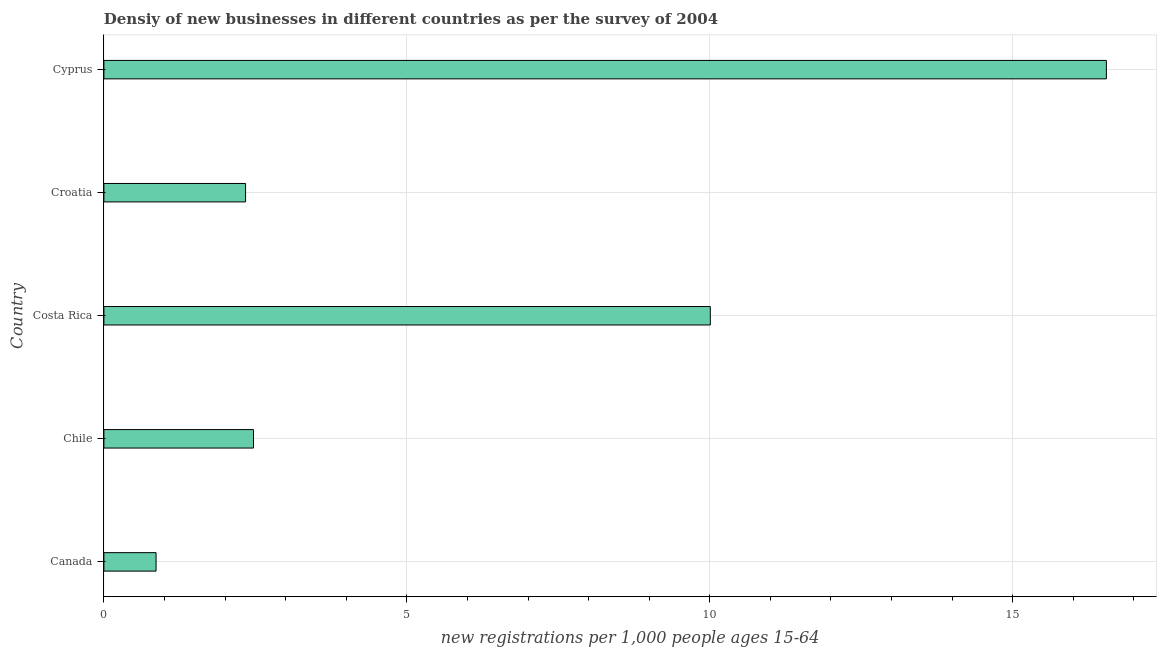Does the graph contain any zero values?
Offer a very short reply. No. Does the graph contain grids?
Your answer should be very brief. Yes. What is the title of the graph?
Offer a very short reply. Densiy of new businesses in different countries as per the survey of 2004. What is the label or title of the X-axis?
Offer a very short reply. New registrations per 1,0 people ages 15-64. What is the density of new business in Cyprus?
Offer a very short reply. 16.55. Across all countries, what is the maximum density of new business?
Provide a succinct answer. 16.55. Across all countries, what is the minimum density of new business?
Give a very brief answer. 0.86. In which country was the density of new business maximum?
Provide a short and direct response. Cyprus. What is the sum of the density of new business?
Give a very brief answer. 32.22. What is the difference between the density of new business in Canada and Cyprus?
Provide a succinct answer. -15.69. What is the average density of new business per country?
Offer a terse response. 6.45. What is the median density of new business?
Ensure brevity in your answer.  2.47. What is the ratio of the density of new business in Croatia to that in Cyprus?
Give a very brief answer. 0.14. Is the density of new business in Costa Rica less than that in Cyprus?
Provide a succinct answer. Yes. What is the difference between the highest and the second highest density of new business?
Offer a very short reply. 6.54. What is the difference between the highest and the lowest density of new business?
Keep it short and to the point. 15.68. How many bars are there?
Your response must be concise. 5. What is the difference between two consecutive major ticks on the X-axis?
Ensure brevity in your answer.  5. Are the values on the major ticks of X-axis written in scientific E-notation?
Ensure brevity in your answer.  No. What is the new registrations per 1,000 people ages 15-64 in Canada?
Ensure brevity in your answer.  0.86. What is the new registrations per 1,000 people ages 15-64 in Chile?
Offer a terse response. 2.47. What is the new registrations per 1,000 people ages 15-64 in Costa Rica?
Give a very brief answer. 10.01. What is the new registrations per 1,000 people ages 15-64 in Croatia?
Ensure brevity in your answer.  2.34. What is the new registrations per 1,000 people ages 15-64 of Cyprus?
Make the answer very short. 16.55. What is the difference between the new registrations per 1,000 people ages 15-64 in Canada and Chile?
Make the answer very short. -1.61. What is the difference between the new registrations per 1,000 people ages 15-64 in Canada and Costa Rica?
Your answer should be compact. -9.15. What is the difference between the new registrations per 1,000 people ages 15-64 in Canada and Croatia?
Give a very brief answer. -1.48. What is the difference between the new registrations per 1,000 people ages 15-64 in Canada and Cyprus?
Keep it short and to the point. -15.68. What is the difference between the new registrations per 1,000 people ages 15-64 in Chile and Costa Rica?
Provide a short and direct response. -7.54. What is the difference between the new registrations per 1,000 people ages 15-64 in Chile and Croatia?
Your response must be concise. 0.13. What is the difference between the new registrations per 1,000 people ages 15-64 in Chile and Cyprus?
Provide a short and direct response. -14.08. What is the difference between the new registrations per 1,000 people ages 15-64 in Costa Rica and Croatia?
Provide a short and direct response. 7.67. What is the difference between the new registrations per 1,000 people ages 15-64 in Costa Rica and Cyprus?
Make the answer very short. -6.54. What is the difference between the new registrations per 1,000 people ages 15-64 in Croatia and Cyprus?
Ensure brevity in your answer.  -14.21. What is the ratio of the new registrations per 1,000 people ages 15-64 in Canada to that in Chile?
Your answer should be very brief. 0.35. What is the ratio of the new registrations per 1,000 people ages 15-64 in Canada to that in Costa Rica?
Offer a very short reply. 0.09. What is the ratio of the new registrations per 1,000 people ages 15-64 in Canada to that in Croatia?
Your response must be concise. 0.37. What is the ratio of the new registrations per 1,000 people ages 15-64 in Canada to that in Cyprus?
Provide a succinct answer. 0.05. What is the ratio of the new registrations per 1,000 people ages 15-64 in Chile to that in Costa Rica?
Provide a short and direct response. 0.25. What is the ratio of the new registrations per 1,000 people ages 15-64 in Chile to that in Croatia?
Offer a terse response. 1.06. What is the ratio of the new registrations per 1,000 people ages 15-64 in Chile to that in Cyprus?
Offer a terse response. 0.15. What is the ratio of the new registrations per 1,000 people ages 15-64 in Costa Rica to that in Croatia?
Provide a succinct answer. 4.28. What is the ratio of the new registrations per 1,000 people ages 15-64 in Costa Rica to that in Cyprus?
Provide a short and direct response. 0.6. What is the ratio of the new registrations per 1,000 people ages 15-64 in Croatia to that in Cyprus?
Offer a terse response. 0.14. 